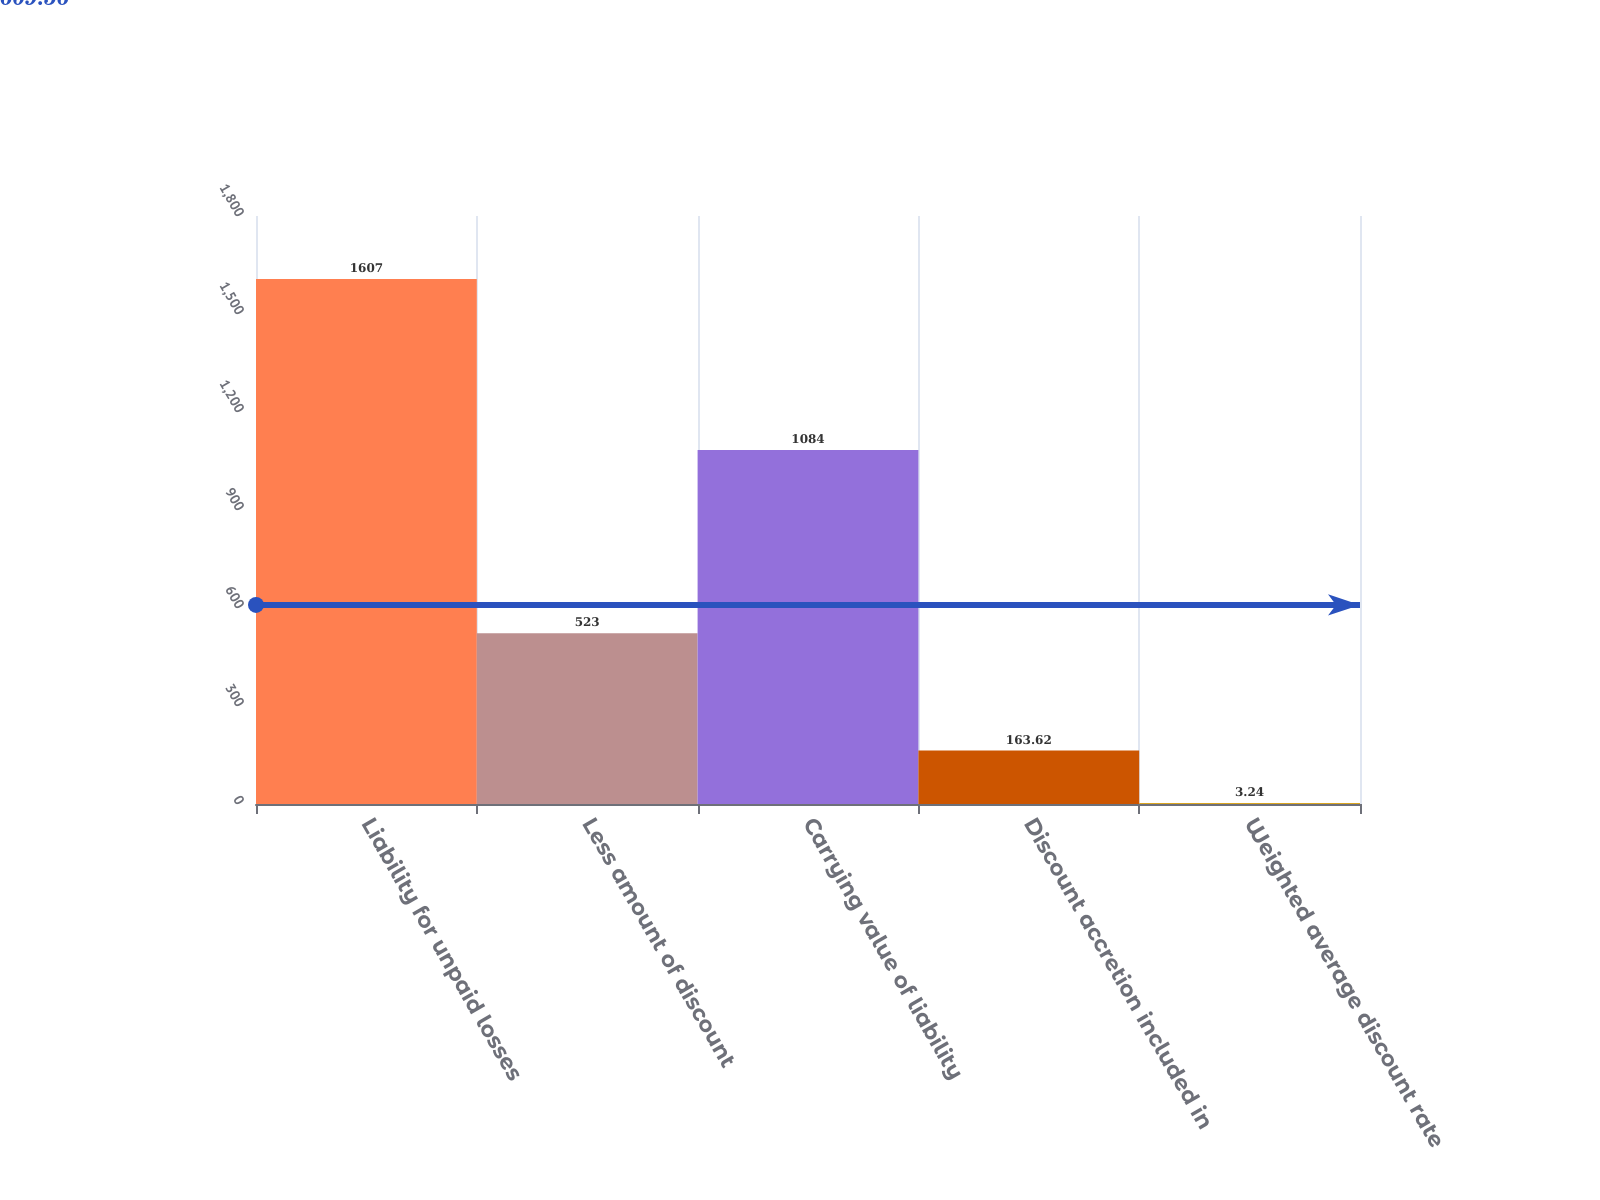Convert chart. <chart><loc_0><loc_0><loc_500><loc_500><bar_chart><fcel>Liability for unpaid losses<fcel>Less amount of discount<fcel>Carrying value of liability<fcel>Discount accretion included in<fcel>Weighted average discount rate<nl><fcel>1607<fcel>523<fcel>1084<fcel>163.62<fcel>3.24<nl></chart> 